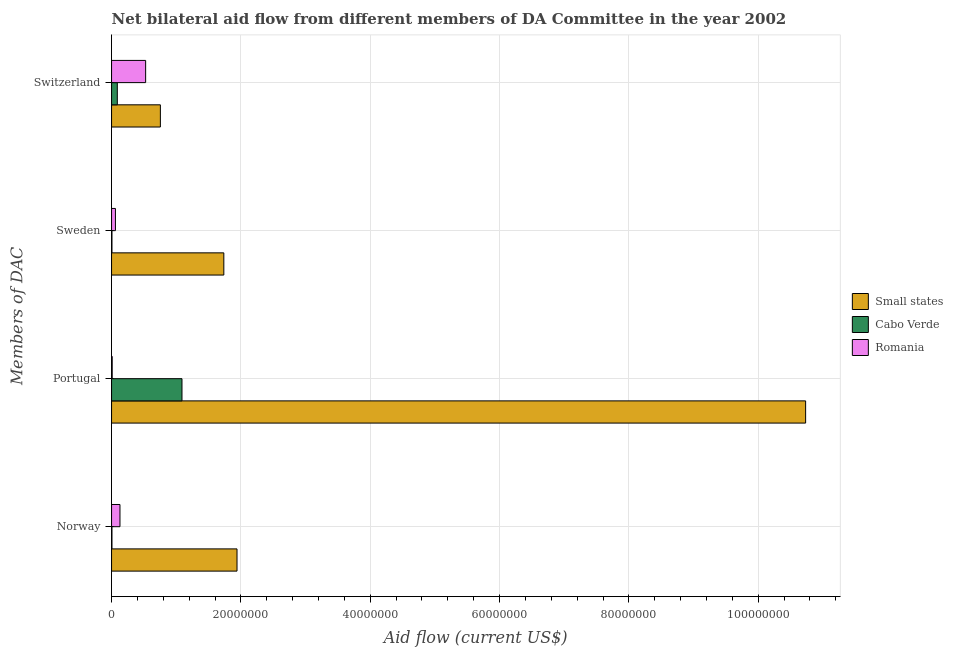How many different coloured bars are there?
Make the answer very short. 3. How many bars are there on the 4th tick from the top?
Your response must be concise. 3. What is the amount of aid given by switzerland in Romania?
Give a very brief answer. 5.27e+06. Across all countries, what is the maximum amount of aid given by portugal?
Keep it short and to the point. 1.07e+08. Across all countries, what is the minimum amount of aid given by norway?
Offer a terse response. 6.00e+04. In which country was the amount of aid given by portugal maximum?
Your answer should be compact. Small states. In which country was the amount of aid given by switzerland minimum?
Make the answer very short. Cabo Verde. What is the total amount of aid given by switzerland in the graph?
Offer a terse response. 1.37e+07. What is the difference between the amount of aid given by portugal in Small states and that in Romania?
Your answer should be compact. 1.07e+08. What is the difference between the amount of aid given by portugal in Romania and the amount of aid given by sweden in Cabo Verde?
Your answer should be compact. 4.00e+04. What is the average amount of aid given by switzerland per country?
Your answer should be very brief. 4.57e+06. What is the difference between the amount of aid given by switzerland and amount of aid given by portugal in Cabo Verde?
Provide a succinct answer. -1.00e+07. In how many countries, is the amount of aid given by portugal greater than 84000000 US$?
Ensure brevity in your answer.  1. What is the ratio of the amount of aid given by norway in Cabo Verde to that in Small states?
Your answer should be very brief. 0. Is the difference between the amount of aid given by norway in Cabo Verde and Romania greater than the difference between the amount of aid given by portugal in Cabo Verde and Romania?
Your answer should be very brief. No. What is the difference between the highest and the second highest amount of aid given by sweden?
Give a very brief answer. 1.68e+07. What is the difference between the highest and the lowest amount of aid given by portugal?
Your answer should be compact. 1.07e+08. In how many countries, is the amount of aid given by portugal greater than the average amount of aid given by portugal taken over all countries?
Keep it short and to the point. 1. Is the sum of the amount of aid given by switzerland in Romania and Cabo Verde greater than the maximum amount of aid given by norway across all countries?
Offer a very short reply. No. Is it the case that in every country, the sum of the amount of aid given by switzerland and amount of aid given by norway is greater than the sum of amount of aid given by portugal and amount of aid given by sweden?
Offer a terse response. No. What does the 3rd bar from the top in Portugal represents?
Your response must be concise. Small states. What does the 2nd bar from the bottom in Switzerland represents?
Make the answer very short. Cabo Verde. How many countries are there in the graph?
Your answer should be very brief. 3. Where does the legend appear in the graph?
Your answer should be compact. Center right. How many legend labels are there?
Provide a succinct answer. 3. What is the title of the graph?
Make the answer very short. Net bilateral aid flow from different members of DA Committee in the year 2002. Does "Bangladesh" appear as one of the legend labels in the graph?
Ensure brevity in your answer.  No. What is the label or title of the X-axis?
Make the answer very short. Aid flow (current US$). What is the label or title of the Y-axis?
Your response must be concise. Members of DAC. What is the Aid flow (current US$) in Small states in Norway?
Your response must be concise. 1.94e+07. What is the Aid flow (current US$) in Cabo Verde in Norway?
Offer a very short reply. 6.00e+04. What is the Aid flow (current US$) in Romania in Norway?
Provide a succinct answer. 1.30e+06. What is the Aid flow (current US$) of Small states in Portugal?
Provide a short and direct response. 1.07e+08. What is the Aid flow (current US$) of Cabo Verde in Portugal?
Your response must be concise. 1.09e+07. What is the Aid flow (current US$) in Romania in Portugal?
Provide a succinct answer. 1.00e+05. What is the Aid flow (current US$) of Small states in Sweden?
Offer a very short reply. 1.74e+07. What is the Aid flow (current US$) of Cabo Verde in Sweden?
Give a very brief answer. 6.00e+04. What is the Aid flow (current US$) in Small states in Switzerland?
Ensure brevity in your answer.  7.55e+06. What is the Aid flow (current US$) in Cabo Verde in Switzerland?
Give a very brief answer. 8.90e+05. What is the Aid flow (current US$) in Romania in Switzerland?
Keep it short and to the point. 5.27e+06. Across all Members of DAC, what is the maximum Aid flow (current US$) in Small states?
Provide a succinct answer. 1.07e+08. Across all Members of DAC, what is the maximum Aid flow (current US$) of Cabo Verde?
Your response must be concise. 1.09e+07. Across all Members of DAC, what is the maximum Aid flow (current US$) in Romania?
Offer a terse response. 5.27e+06. Across all Members of DAC, what is the minimum Aid flow (current US$) in Small states?
Ensure brevity in your answer.  7.55e+06. Across all Members of DAC, what is the minimum Aid flow (current US$) of Cabo Verde?
Provide a short and direct response. 6.00e+04. What is the total Aid flow (current US$) in Small states in the graph?
Make the answer very short. 1.52e+08. What is the total Aid flow (current US$) in Cabo Verde in the graph?
Your response must be concise. 1.19e+07. What is the total Aid flow (current US$) of Romania in the graph?
Provide a succinct answer. 7.27e+06. What is the difference between the Aid flow (current US$) of Small states in Norway and that in Portugal?
Your response must be concise. -8.79e+07. What is the difference between the Aid flow (current US$) in Cabo Verde in Norway and that in Portugal?
Ensure brevity in your answer.  -1.08e+07. What is the difference between the Aid flow (current US$) in Romania in Norway and that in Portugal?
Offer a terse response. 1.20e+06. What is the difference between the Aid flow (current US$) of Small states in Norway and that in Sweden?
Give a very brief answer. 2.04e+06. What is the difference between the Aid flow (current US$) of Romania in Norway and that in Sweden?
Your answer should be very brief. 7.00e+05. What is the difference between the Aid flow (current US$) of Small states in Norway and that in Switzerland?
Keep it short and to the point. 1.18e+07. What is the difference between the Aid flow (current US$) of Cabo Verde in Norway and that in Switzerland?
Offer a terse response. -8.30e+05. What is the difference between the Aid flow (current US$) of Romania in Norway and that in Switzerland?
Offer a terse response. -3.97e+06. What is the difference between the Aid flow (current US$) of Small states in Portugal and that in Sweden?
Offer a terse response. 9.00e+07. What is the difference between the Aid flow (current US$) in Cabo Verde in Portugal and that in Sweden?
Offer a terse response. 1.08e+07. What is the difference between the Aid flow (current US$) of Romania in Portugal and that in Sweden?
Your answer should be very brief. -5.00e+05. What is the difference between the Aid flow (current US$) of Small states in Portugal and that in Switzerland?
Give a very brief answer. 9.98e+07. What is the difference between the Aid flow (current US$) in Romania in Portugal and that in Switzerland?
Make the answer very short. -5.17e+06. What is the difference between the Aid flow (current US$) in Small states in Sweden and that in Switzerland?
Your answer should be compact. 9.81e+06. What is the difference between the Aid flow (current US$) in Cabo Verde in Sweden and that in Switzerland?
Provide a succinct answer. -8.30e+05. What is the difference between the Aid flow (current US$) in Romania in Sweden and that in Switzerland?
Make the answer very short. -4.67e+06. What is the difference between the Aid flow (current US$) of Small states in Norway and the Aid flow (current US$) of Cabo Verde in Portugal?
Offer a very short reply. 8.51e+06. What is the difference between the Aid flow (current US$) in Small states in Norway and the Aid flow (current US$) in Romania in Portugal?
Ensure brevity in your answer.  1.93e+07. What is the difference between the Aid flow (current US$) of Small states in Norway and the Aid flow (current US$) of Cabo Verde in Sweden?
Your answer should be very brief. 1.93e+07. What is the difference between the Aid flow (current US$) of Small states in Norway and the Aid flow (current US$) of Romania in Sweden?
Keep it short and to the point. 1.88e+07. What is the difference between the Aid flow (current US$) in Cabo Verde in Norway and the Aid flow (current US$) in Romania in Sweden?
Your answer should be compact. -5.40e+05. What is the difference between the Aid flow (current US$) of Small states in Norway and the Aid flow (current US$) of Cabo Verde in Switzerland?
Your response must be concise. 1.85e+07. What is the difference between the Aid flow (current US$) in Small states in Norway and the Aid flow (current US$) in Romania in Switzerland?
Provide a short and direct response. 1.41e+07. What is the difference between the Aid flow (current US$) of Cabo Verde in Norway and the Aid flow (current US$) of Romania in Switzerland?
Keep it short and to the point. -5.21e+06. What is the difference between the Aid flow (current US$) in Small states in Portugal and the Aid flow (current US$) in Cabo Verde in Sweden?
Offer a terse response. 1.07e+08. What is the difference between the Aid flow (current US$) in Small states in Portugal and the Aid flow (current US$) in Romania in Sweden?
Offer a terse response. 1.07e+08. What is the difference between the Aid flow (current US$) of Cabo Verde in Portugal and the Aid flow (current US$) of Romania in Sweden?
Ensure brevity in your answer.  1.03e+07. What is the difference between the Aid flow (current US$) of Small states in Portugal and the Aid flow (current US$) of Cabo Verde in Switzerland?
Ensure brevity in your answer.  1.06e+08. What is the difference between the Aid flow (current US$) of Small states in Portugal and the Aid flow (current US$) of Romania in Switzerland?
Give a very brief answer. 1.02e+08. What is the difference between the Aid flow (current US$) of Cabo Verde in Portugal and the Aid flow (current US$) of Romania in Switzerland?
Give a very brief answer. 5.62e+06. What is the difference between the Aid flow (current US$) of Small states in Sweden and the Aid flow (current US$) of Cabo Verde in Switzerland?
Ensure brevity in your answer.  1.65e+07. What is the difference between the Aid flow (current US$) of Small states in Sweden and the Aid flow (current US$) of Romania in Switzerland?
Provide a succinct answer. 1.21e+07. What is the difference between the Aid flow (current US$) of Cabo Verde in Sweden and the Aid flow (current US$) of Romania in Switzerland?
Ensure brevity in your answer.  -5.21e+06. What is the average Aid flow (current US$) of Small states per Members of DAC?
Keep it short and to the point. 3.79e+07. What is the average Aid flow (current US$) of Cabo Verde per Members of DAC?
Your answer should be very brief. 2.98e+06. What is the average Aid flow (current US$) of Romania per Members of DAC?
Your answer should be compact. 1.82e+06. What is the difference between the Aid flow (current US$) in Small states and Aid flow (current US$) in Cabo Verde in Norway?
Your response must be concise. 1.93e+07. What is the difference between the Aid flow (current US$) in Small states and Aid flow (current US$) in Romania in Norway?
Keep it short and to the point. 1.81e+07. What is the difference between the Aid flow (current US$) in Cabo Verde and Aid flow (current US$) in Romania in Norway?
Offer a terse response. -1.24e+06. What is the difference between the Aid flow (current US$) of Small states and Aid flow (current US$) of Cabo Verde in Portugal?
Make the answer very short. 9.64e+07. What is the difference between the Aid flow (current US$) of Small states and Aid flow (current US$) of Romania in Portugal?
Give a very brief answer. 1.07e+08. What is the difference between the Aid flow (current US$) in Cabo Verde and Aid flow (current US$) in Romania in Portugal?
Your answer should be compact. 1.08e+07. What is the difference between the Aid flow (current US$) in Small states and Aid flow (current US$) in Cabo Verde in Sweden?
Ensure brevity in your answer.  1.73e+07. What is the difference between the Aid flow (current US$) of Small states and Aid flow (current US$) of Romania in Sweden?
Offer a terse response. 1.68e+07. What is the difference between the Aid flow (current US$) of Cabo Verde and Aid flow (current US$) of Romania in Sweden?
Provide a succinct answer. -5.40e+05. What is the difference between the Aid flow (current US$) in Small states and Aid flow (current US$) in Cabo Verde in Switzerland?
Provide a succinct answer. 6.66e+06. What is the difference between the Aid flow (current US$) of Small states and Aid flow (current US$) of Romania in Switzerland?
Your answer should be very brief. 2.28e+06. What is the difference between the Aid flow (current US$) in Cabo Verde and Aid flow (current US$) in Romania in Switzerland?
Provide a succinct answer. -4.38e+06. What is the ratio of the Aid flow (current US$) in Small states in Norway to that in Portugal?
Your answer should be compact. 0.18. What is the ratio of the Aid flow (current US$) in Cabo Verde in Norway to that in Portugal?
Offer a very short reply. 0.01. What is the ratio of the Aid flow (current US$) in Romania in Norway to that in Portugal?
Ensure brevity in your answer.  13. What is the ratio of the Aid flow (current US$) of Small states in Norway to that in Sweden?
Provide a succinct answer. 1.12. What is the ratio of the Aid flow (current US$) in Romania in Norway to that in Sweden?
Your answer should be very brief. 2.17. What is the ratio of the Aid flow (current US$) of Small states in Norway to that in Switzerland?
Your answer should be compact. 2.57. What is the ratio of the Aid flow (current US$) in Cabo Verde in Norway to that in Switzerland?
Ensure brevity in your answer.  0.07. What is the ratio of the Aid flow (current US$) of Romania in Norway to that in Switzerland?
Make the answer very short. 0.25. What is the ratio of the Aid flow (current US$) in Small states in Portugal to that in Sweden?
Offer a very short reply. 6.18. What is the ratio of the Aid flow (current US$) in Cabo Verde in Portugal to that in Sweden?
Give a very brief answer. 181.5. What is the ratio of the Aid flow (current US$) in Small states in Portugal to that in Switzerland?
Provide a succinct answer. 14.22. What is the ratio of the Aid flow (current US$) in Cabo Verde in Portugal to that in Switzerland?
Ensure brevity in your answer.  12.24. What is the ratio of the Aid flow (current US$) in Romania in Portugal to that in Switzerland?
Your answer should be very brief. 0.02. What is the ratio of the Aid flow (current US$) of Small states in Sweden to that in Switzerland?
Your response must be concise. 2.3. What is the ratio of the Aid flow (current US$) in Cabo Verde in Sweden to that in Switzerland?
Offer a very short reply. 0.07. What is the ratio of the Aid flow (current US$) of Romania in Sweden to that in Switzerland?
Your answer should be compact. 0.11. What is the difference between the highest and the second highest Aid flow (current US$) in Small states?
Your answer should be very brief. 8.79e+07. What is the difference between the highest and the second highest Aid flow (current US$) of Romania?
Your answer should be very brief. 3.97e+06. What is the difference between the highest and the lowest Aid flow (current US$) of Small states?
Make the answer very short. 9.98e+07. What is the difference between the highest and the lowest Aid flow (current US$) in Cabo Verde?
Ensure brevity in your answer.  1.08e+07. What is the difference between the highest and the lowest Aid flow (current US$) of Romania?
Keep it short and to the point. 5.17e+06. 